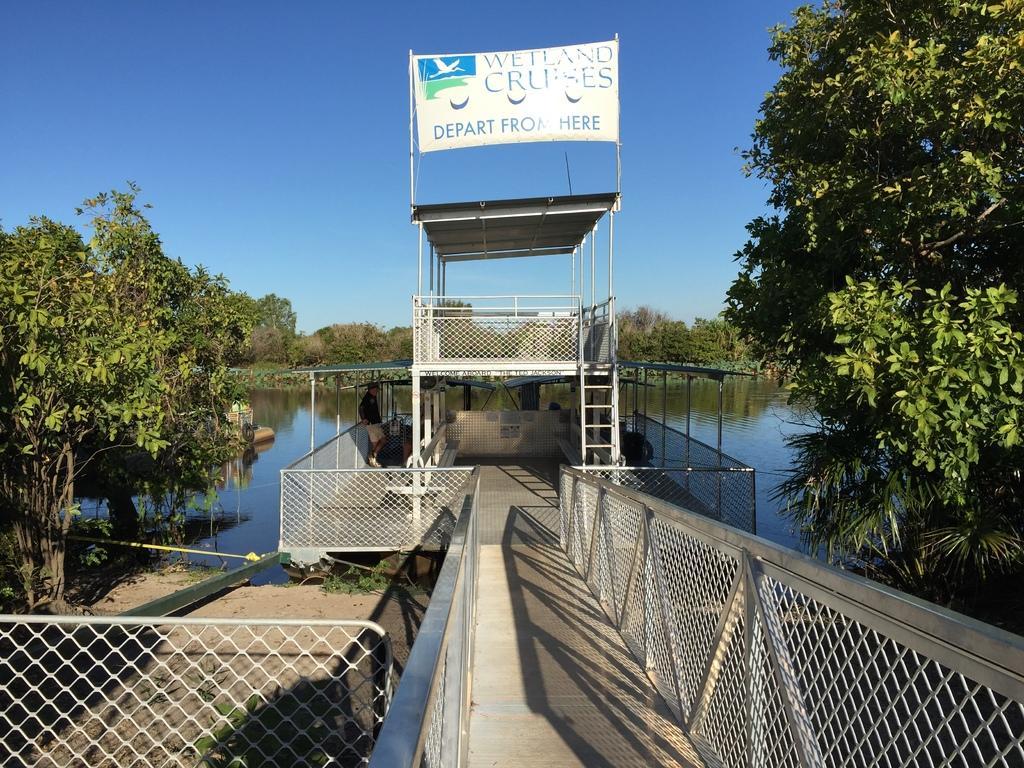Could you give a brief overview of what you see in this image? In the center of the image we can see a board bridge and there is a board. We can see trees and water. In the background there is sky. At the bottom there is a mesh. 